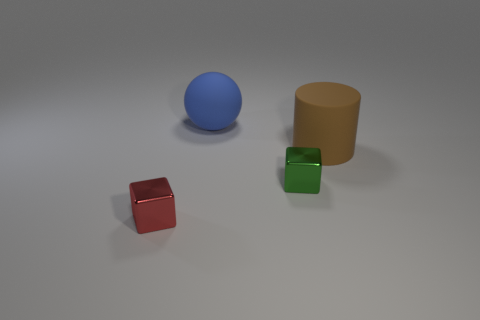How many tiny objects are blue balls or yellow rubber cubes?
Keep it short and to the point. 0. There is a shiny object on the right side of the large object that is behind the big rubber cylinder; what color is it?
Your answer should be very brief. Green. Do the big cylinder and the big thing on the left side of the tiny green cube have the same material?
Your response must be concise. Yes. There is a large thing that is to the left of the small green metallic thing; what material is it?
Provide a succinct answer. Rubber. Are there the same number of tiny red shiny things that are behind the big ball and yellow rubber cylinders?
Ensure brevity in your answer.  Yes. There is a thing behind the cylinder behind the small green metallic object; what is it made of?
Your answer should be compact. Rubber. What is the shape of the thing that is both right of the blue object and behind the green object?
Provide a succinct answer. Cylinder. Is the number of cylinders that are on the left side of the large brown matte thing less than the number of metallic blocks?
Offer a very short reply. Yes. How big is the matte object on the left side of the large brown thing?
Your answer should be compact. Large. There is another metal thing that is the same shape as the red thing; what color is it?
Provide a succinct answer. Green. 